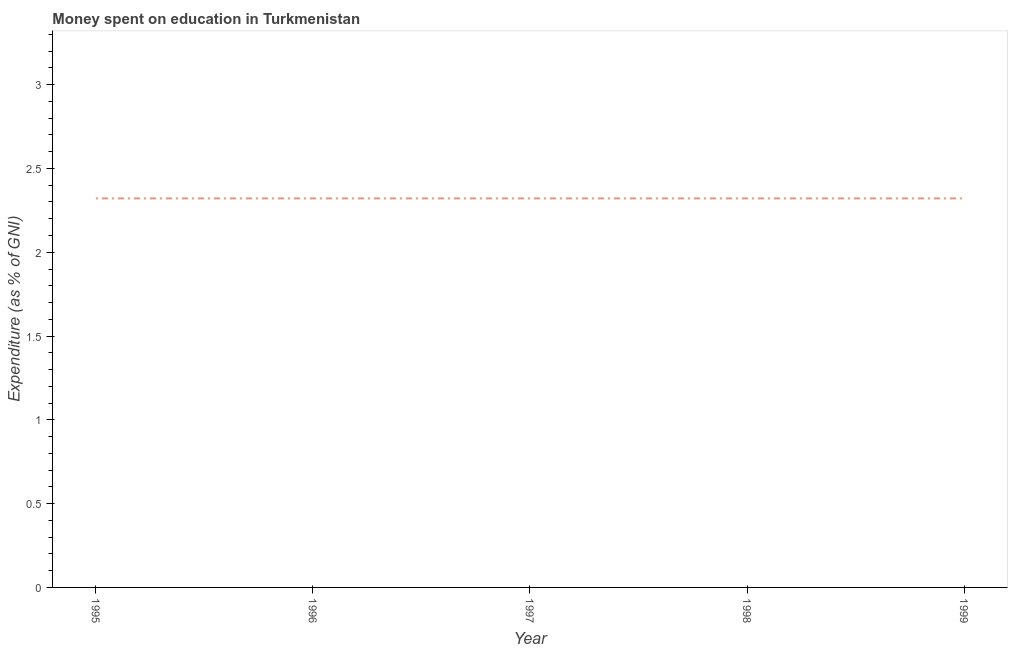What is the expenditure on education in 1997?
Your answer should be compact. 2.32. Across all years, what is the maximum expenditure on education?
Your answer should be compact. 2.32. Across all years, what is the minimum expenditure on education?
Your answer should be compact. 2.32. In which year was the expenditure on education maximum?
Keep it short and to the point. 1995. What is the sum of the expenditure on education?
Offer a very short reply. 11.61. What is the average expenditure on education per year?
Offer a terse response. 2.32. What is the median expenditure on education?
Provide a short and direct response. 2.32. In how many years, is the expenditure on education greater than 0.30000000000000004 %?
Ensure brevity in your answer.  5. Is the expenditure on education in 1996 less than that in 1997?
Your answer should be very brief. No. What is the difference between the highest and the second highest expenditure on education?
Offer a very short reply. 0. Is the sum of the expenditure on education in 1997 and 1999 greater than the maximum expenditure on education across all years?
Offer a very short reply. Yes. In how many years, is the expenditure on education greater than the average expenditure on education taken over all years?
Ensure brevity in your answer.  0. Does the expenditure on education monotonically increase over the years?
Provide a succinct answer. No. How many years are there in the graph?
Provide a succinct answer. 5. What is the difference between two consecutive major ticks on the Y-axis?
Provide a succinct answer. 0.5. Does the graph contain grids?
Make the answer very short. No. What is the title of the graph?
Provide a succinct answer. Money spent on education in Turkmenistan. What is the label or title of the X-axis?
Ensure brevity in your answer.  Year. What is the label or title of the Y-axis?
Provide a succinct answer. Expenditure (as % of GNI). What is the Expenditure (as % of GNI) in 1995?
Make the answer very short. 2.32. What is the Expenditure (as % of GNI) of 1996?
Provide a short and direct response. 2.32. What is the Expenditure (as % of GNI) of 1997?
Ensure brevity in your answer.  2.32. What is the Expenditure (as % of GNI) of 1998?
Offer a very short reply. 2.32. What is the Expenditure (as % of GNI) of 1999?
Keep it short and to the point. 2.32. What is the difference between the Expenditure (as % of GNI) in 1995 and 1996?
Provide a succinct answer. 0. What is the difference between the Expenditure (as % of GNI) in 1995 and 1998?
Your answer should be compact. 0. What is the difference between the Expenditure (as % of GNI) in 1995 and 1999?
Offer a terse response. 0. What is the difference between the Expenditure (as % of GNI) in 1996 and 1999?
Give a very brief answer. 0. What is the difference between the Expenditure (as % of GNI) in 1997 and 1999?
Keep it short and to the point. 0. What is the difference between the Expenditure (as % of GNI) in 1998 and 1999?
Provide a succinct answer. 0. What is the ratio of the Expenditure (as % of GNI) in 1995 to that in 1996?
Your response must be concise. 1. What is the ratio of the Expenditure (as % of GNI) in 1995 to that in 1997?
Your answer should be very brief. 1. What is the ratio of the Expenditure (as % of GNI) in 1997 to that in 1999?
Give a very brief answer. 1. What is the ratio of the Expenditure (as % of GNI) in 1998 to that in 1999?
Offer a very short reply. 1. 